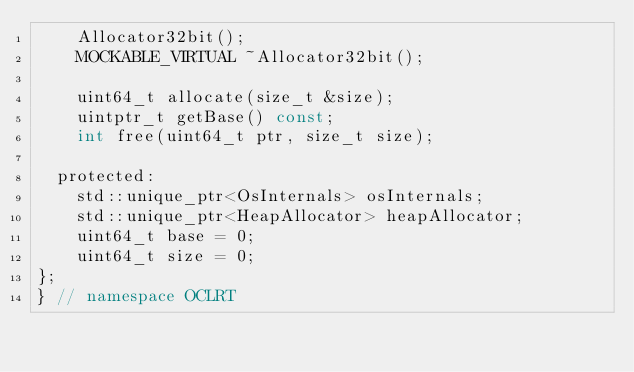Convert code to text. <code><loc_0><loc_0><loc_500><loc_500><_C_>    Allocator32bit();
    MOCKABLE_VIRTUAL ~Allocator32bit();

    uint64_t allocate(size_t &size);
    uintptr_t getBase() const;
    int free(uint64_t ptr, size_t size);

  protected:
    std::unique_ptr<OsInternals> osInternals;
    std::unique_ptr<HeapAllocator> heapAllocator;
    uint64_t base = 0;
    uint64_t size = 0;
};
} // namespace OCLRT
</code> 